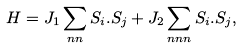Convert formula to latex. <formula><loc_0><loc_0><loc_500><loc_500>H = J _ { 1 } \sum _ { n n } { S } _ { i } . { S } _ { j } + J _ { 2 } \sum _ { n n n } { S } _ { i } . { S } _ { j } ,</formula> 